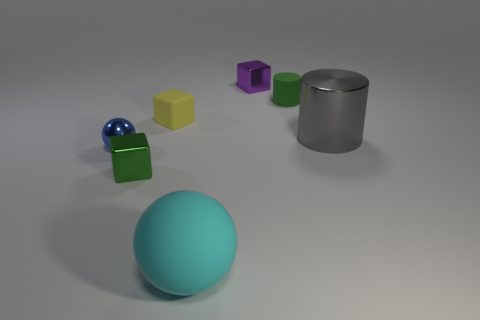Add 1 tiny cyan shiny cylinders. How many objects exist? 8 Subtract all cylinders. How many objects are left? 5 Subtract 0 blue blocks. How many objects are left? 7 Subtract all tiny blue shiny things. Subtract all green metallic things. How many objects are left? 5 Add 5 shiny cylinders. How many shiny cylinders are left? 6 Add 6 purple objects. How many purple objects exist? 7 